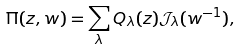<formula> <loc_0><loc_0><loc_500><loc_500>\Pi ( z , w ) = \sum _ { \lambda } Q _ { \lambda } ( z ) \mathcal { J } _ { \lambda } ( w ^ { - 1 } ) ,</formula> 